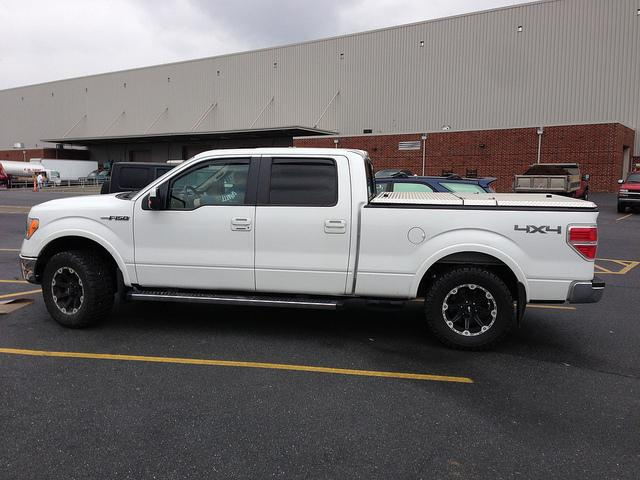What would the answer to the equation on the truck be if the x is replaced by a sign? Please explain your reasoning. eight. If it were a plus sign it would equal 8. 